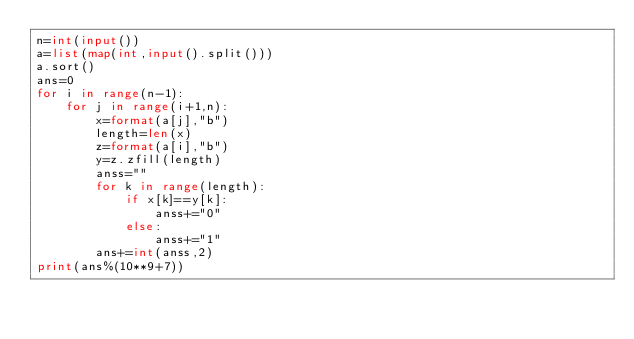Convert code to text. <code><loc_0><loc_0><loc_500><loc_500><_Python_>n=int(input())
a=list(map(int,input().split()))
a.sort()
ans=0
for i in range(n-1):
    for j in range(i+1,n):
        x=format(a[j],"b")
        length=len(x)
        z=format(a[i],"b")
        y=z.zfill(length)
        anss=""
        for k in range(length):
            if x[k]==y[k]:
                anss+="0"
            else:
                anss+="1" 
        ans+=int(anss,2) 
print(ans%(10**9+7))                      
                </code> 